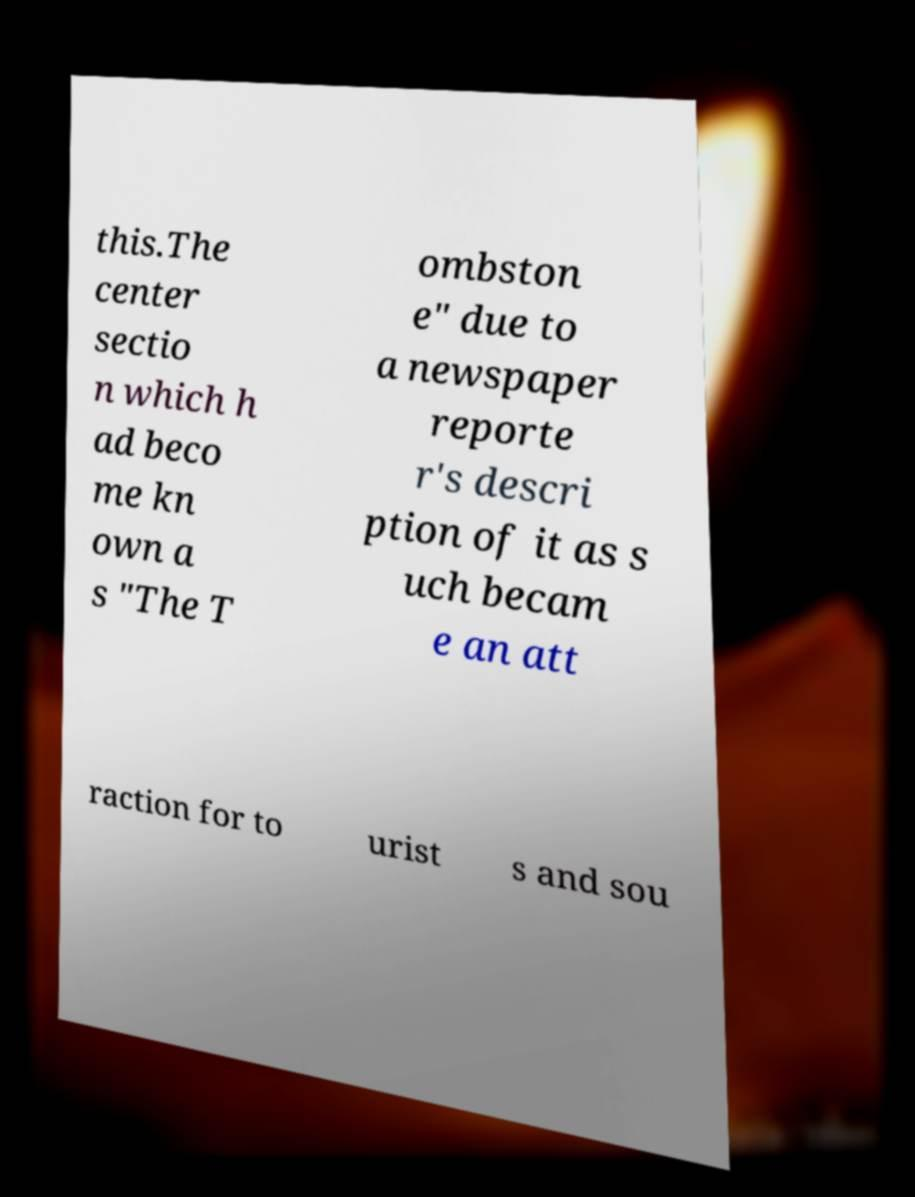Can you read and provide the text displayed in the image?This photo seems to have some interesting text. Can you extract and type it out for me? this.The center sectio n which h ad beco me kn own a s "The T ombston e" due to a newspaper reporte r's descri ption of it as s uch becam e an att raction for to urist s and sou 